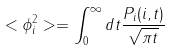Convert formula to latex. <formula><loc_0><loc_0><loc_500><loc_500>< \phi ^ { 2 } _ { i } > = \int _ { 0 } ^ { \infty } d t \frac { P _ { i } ( i , t ) } { \sqrt { \pi t } }</formula> 